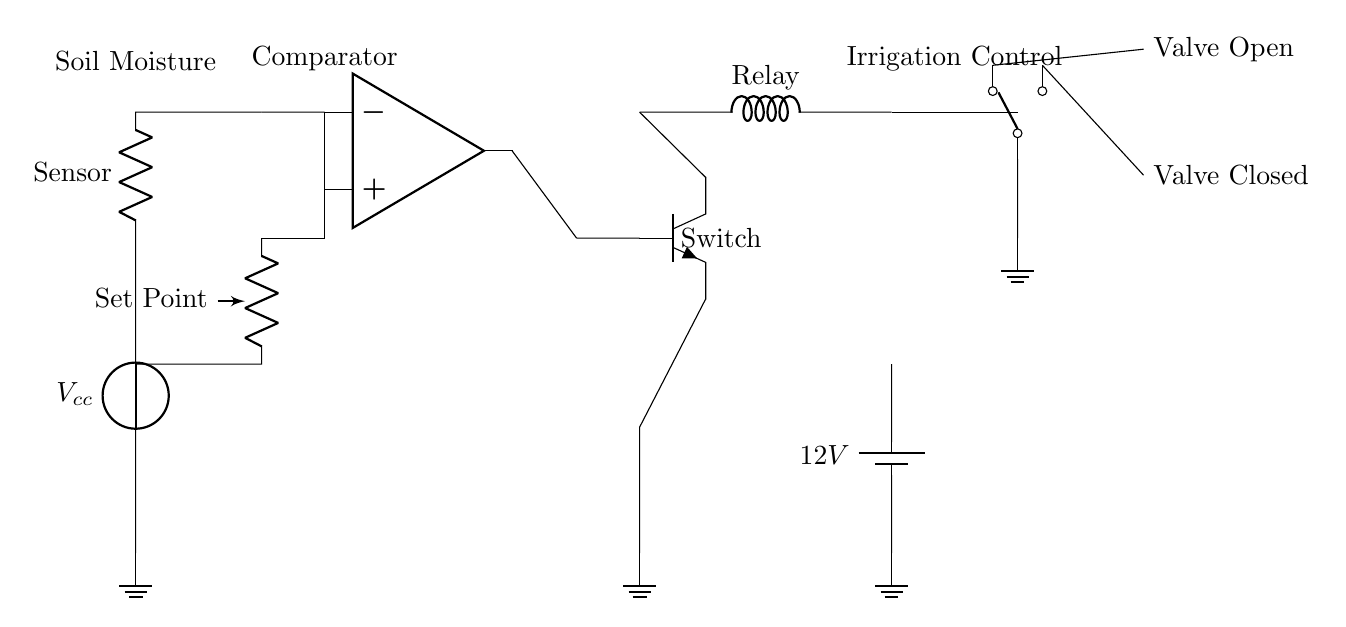What is the power supply voltage? The power supply voltage is labeled as 12V in the circuit. This is indicated next to the battery component in the diagram.
Answer: 12V What type of sensor is used in this circuit? The circuit employs a soil moisture sensor, as denoted in the labels within the diagram. This component measures the moisture level in the soil.
Answer: Soil moisture sensor What is the role of the comparator in this circuit? The comparator compares the output from the soil moisture sensor with a set reference voltage. Based on this comparison, it will trigger the transistor to control the irrigation system.
Answer: To compare voltages How does the irrigation valve operate? The irrigation valve operates through a switch controlled by a relay, which is activated by the output of the transistor. When the conditions are met, the valve opens to allow water flow.
Answer: It opens or closes the water flow What component acts as the controller for the irrigation system? The transistor functions as the controller for the irrigation system, as it regulates the flow of current based on the input from the comparator. This regulates the relay and the valve.
Answer: Transistor What is the function of the potentiometer in this circuit? The potentiometer is used to set a reference voltage or set point for the comparator. By adjusting it, you can change the moisture threshold that triggers irrigation.
Answer: To set a reference voltage 